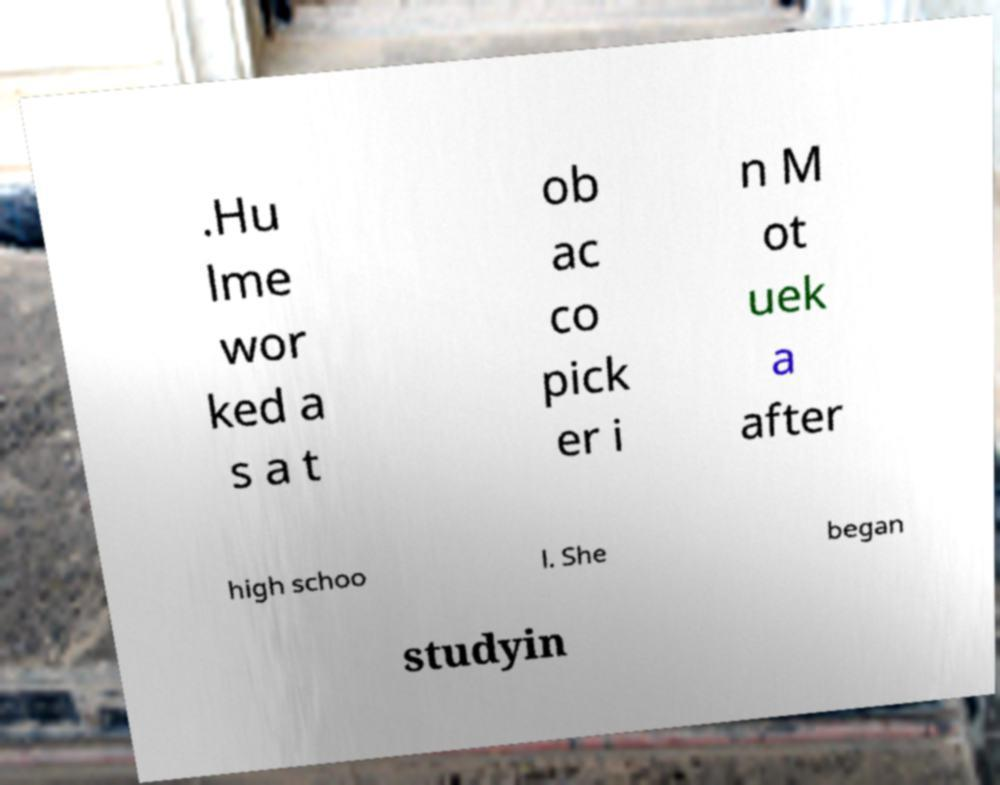I need the written content from this picture converted into text. Can you do that? .Hu lme wor ked a s a t ob ac co pick er i n M ot uek a after high schoo l. She began studyin 